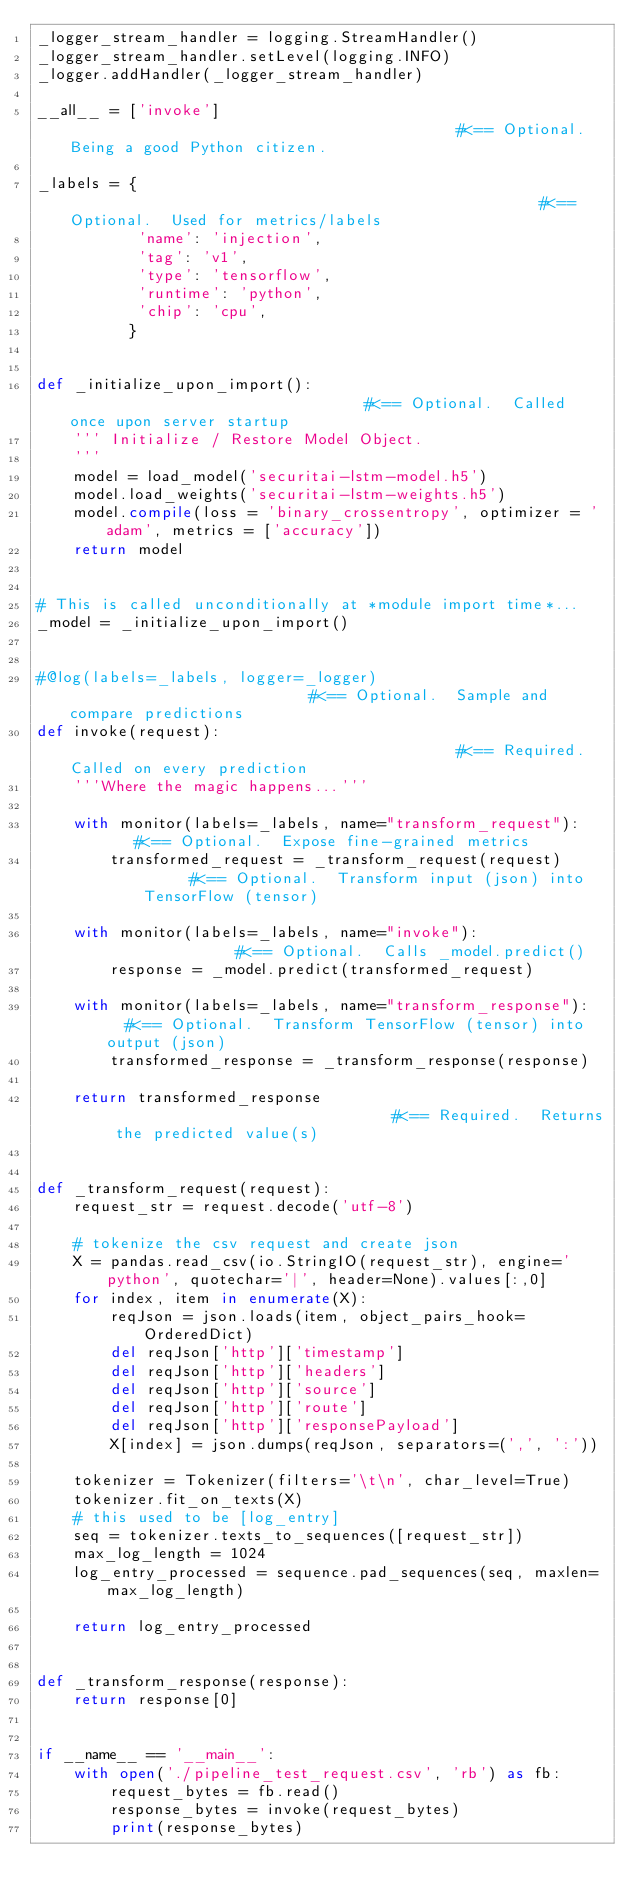<code> <loc_0><loc_0><loc_500><loc_500><_Python_>_logger_stream_handler = logging.StreamHandler()
_logger_stream_handler.setLevel(logging.INFO)
_logger.addHandler(_logger_stream_handler)

__all__ = ['invoke']                                           #<== Optional.  Being a good Python citizen.

_labels = {                                                    #<== Optional.  Used for metrics/labels
           'name': 'injection',
           'tag': 'v1',
           'type': 'tensorflow',
           'runtime': 'python',
           'chip': 'cpu',
          }


def _initialize_upon_import():                                 #<== Optional.  Called once upon server startup
    ''' Initialize / Restore Model Object.
    '''
    model = load_model('securitai-lstm-model.h5')
    model.load_weights('securitai-lstm-weights.h5')
    model.compile(loss = 'binary_crossentropy', optimizer = 'adam', metrics = ['accuracy'])
    return model


# This is called unconditionally at *module import time*...
_model = _initialize_upon_import()


#@log(labels=_labels, logger=_logger)                           #<== Optional.  Sample and compare predictions
def invoke(request):                                           #<== Required.  Called on every prediction
    '''Where the magic happens...'''

    with monitor(labels=_labels, name="transform_request"):    #<== Optional.  Expose fine-grained metrics
        transformed_request = _transform_request(request)      #<== Optional.  Transform input (json) into TensorFlow (tensor)

    with monitor(labels=_labels, name="invoke"):               #<== Optional.  Calls _model.predict()
        response = _model.predict(transformed_request)

    with monitor(labels=_labels, name="transform_response"):   #<== Optional.  Transform TensorFlow (tensor) into output (json)
        transformed_response = _transform_response(response)

    return transformed_response                                #<== Required.  Returns the predicted value(s)


def _transform_request(request):
    request_str = request.decode('utf-8')

    # tokenize the csv request and create json
    X = pandas.read_csv(io.StringIO(request_str), engine='python', quotechar='|', header=None).values[:,0]
    for index, item in enumerate(X):
        reqJson = json.loads(item, object_pairs_hook=OrderedDict)
        del reqJson['http']['timestamp']
        del reqJson['http']['headers']
        del reqJson['http']['source']
        del reqJson['http']['route']
        del reqJson['http']['responsePayload']
        X[index] = json.dumps(reqJson, separators=(',', ':'))

    tokenizer = Tokenizer(filters='\t\n', char_level=True)
    tokenizer.fit_on_texts(X)
    # this used to be [log_entry]
    seq = tokenizer.texts_to_sequences([request_str])
    max_log_length = 1024
    log_entry_processed = sequence.pad_sequences(seq, maxlen=max_log_length)

    return log_entry_processed 


def _transform_response(response):
    return response[0]


if __name__ == '__main__':
    with open('./pipeline_test_request.csv', 'rb') as fb:
        request_bytes = fb.read()
        response_bytes = invoke(request_bytes)
        print(response_bytes)
</code> 